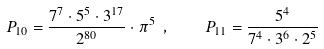<formula> <loc_0><loc_0><loc_500><loc_500>P _ { 1 0 } = \frac { 7 ^ { 7 } \cdot 5 ^ { 5 } \cdot 3 ^ { 1 7 } } { 2 ^ { 8 0 } } \cdot \pi ^ { 5 } \ , \quad P _ { 1 1 } = \frac { 5 ^ { 4 } } { 7 ^ { 4 } \cdot 3 ^ { 6 } \cdot 2 ^ { 5 } }</formula> 